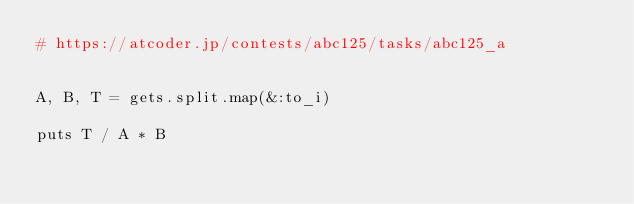<code> <loc_0><loc_0><loc_500><loc_500><_Ruby_># https://atcoder.jp/contests/abc125/tasks/abc125_a


A, B, T = gets.split.map(&:to_i)

puts T / A * B
</code> 